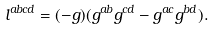<formula> <loc_0><loc_0><loc_500><loc_500>l ^ { a b c d } = ( - g ) ( g ^ { a b } g ^ { c d } - g ^ { a c } g ^ { b d } ) .</formula> 